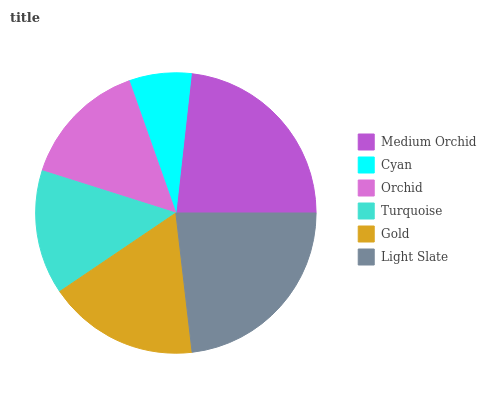Is Cyan the minimum?
Answer yes or no. Yes. Is Medium Orchid the maximum?
Answer yes or no. Yes. Is Orchid the minimum?
Answer yes or no. No. Is Orchid the maximum?
Answer yes or no. No. Is Orchid greater than Cyan?
Answer yes or no. Yes. Is Cyan less than Orchid?
Answer yes or no. Yes. Is Cyan greater than Orchid?
Answer yes or no. No. Is Orchid less than Cyan?
Answer yes or no. No. Is Gold the high median?
Answer yes or no. Yes. Is Orchid the low median?
Answer yes or no. Yes. Is Turquoise the high median?
Answer yes or no. No. Is Cyan the low median?
Answer yes or no. No. 